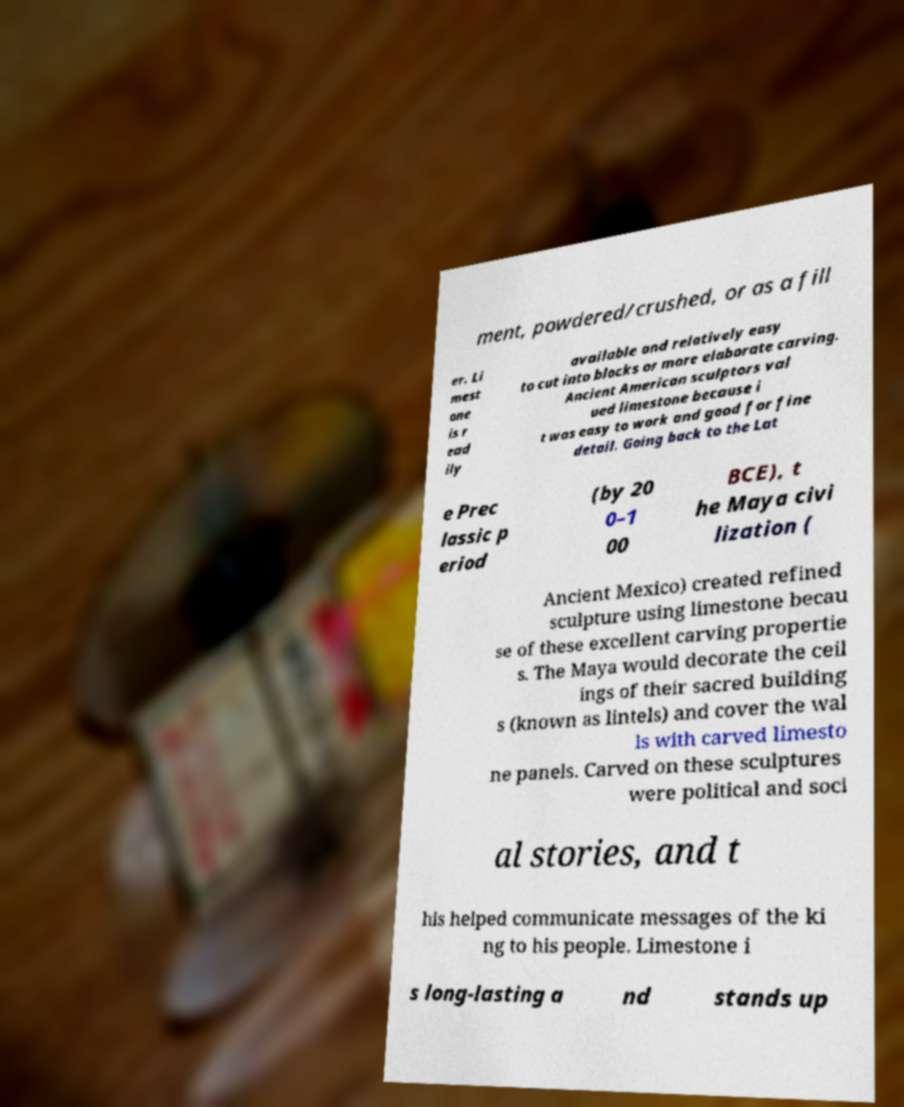For documentation purposes, I need the text within this image transcribed. Could you provide that? ment, powdered/crushed, or as a fill er. Li mest one is r ead ily available and relatively easy to cut into blocks or more elaborate carving. Ancient American sculptors val ued limestone because i t was easy to work and good for fine detail. Going back to the Lat e Prec lassic p eriod (by 20 0–1 00 BCE), t he Maya civi lization ( Ancient Mexico) created refined sculpture using limestone becau se of these excellent carving propertie s. The Maya would decorate the ceil ings of their sacred building s (known as lintels) and cover the wal ls with carved limesto ne panels. Carved on these sculptures were political and soci al stories, and t his helped communicate messages of the ki ng to his people. Limestone i s long-lasting a nd stands up 